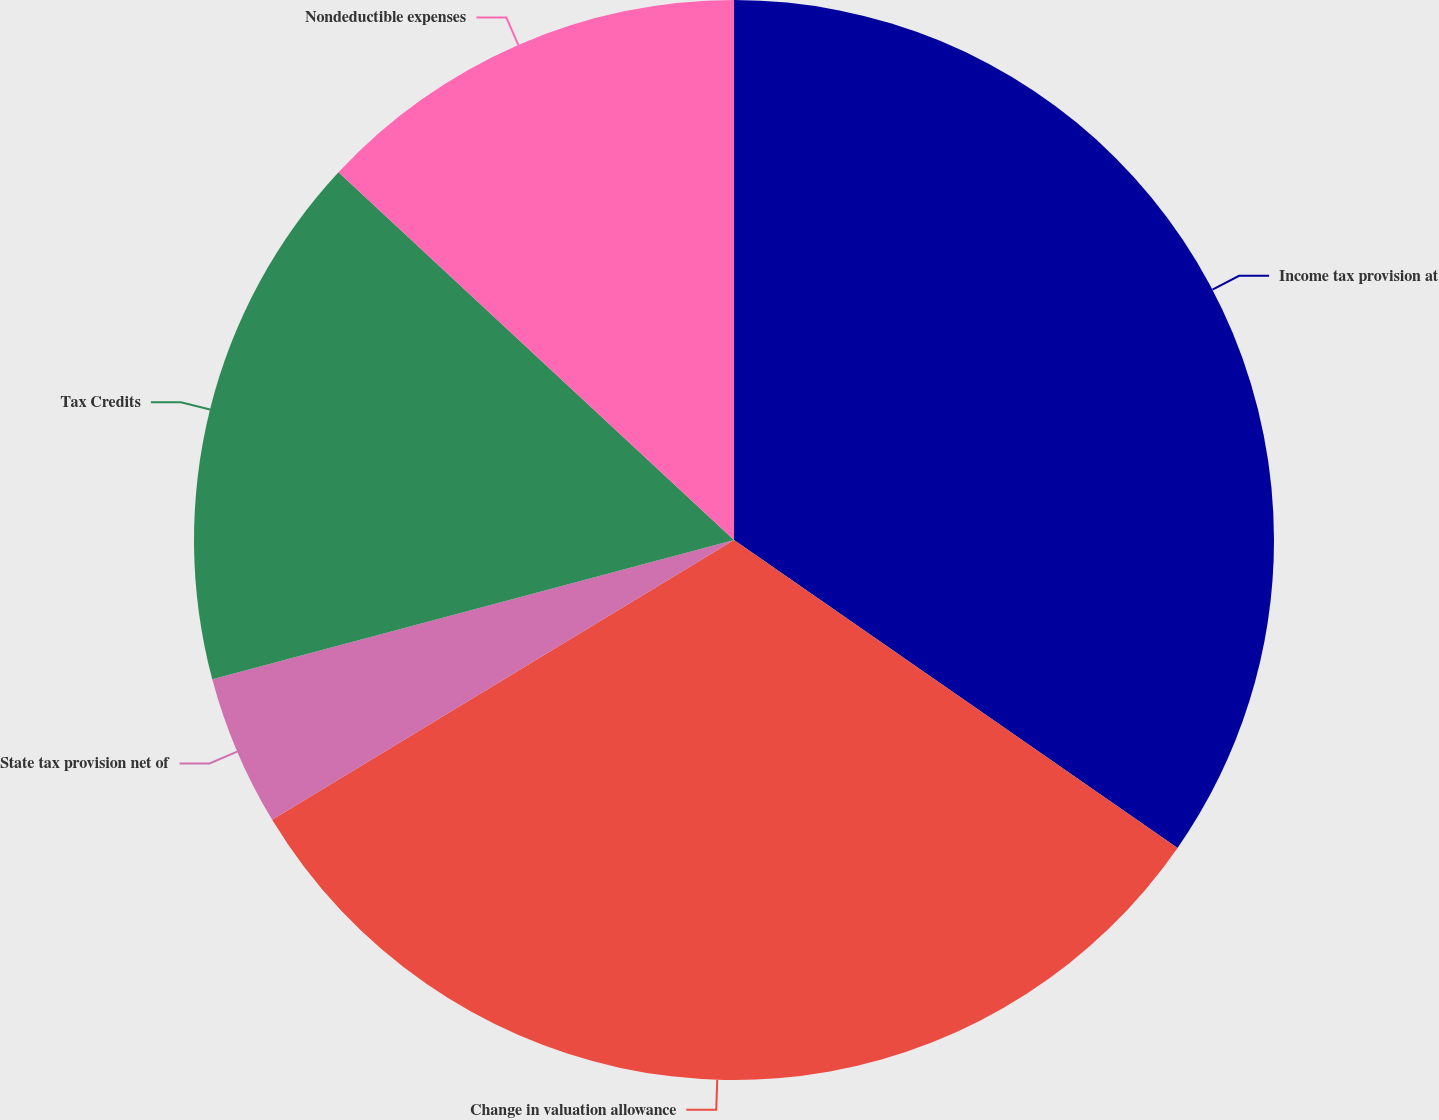Convert chart to OTSL. <chart><loc_0><loc_0><loc_500><loc_500><pie_chart><fcel>Income tax provision at<fcel>Change in valuation allowance<fcel>State tax provision net of<fcel>Tax Credits<fcel>Nondeductible expenses<nl><fcel>34.66%<fcel>31.67%<fcel>4.52%<fcel>16.07%<fcel>13.08%<nl></chart> 